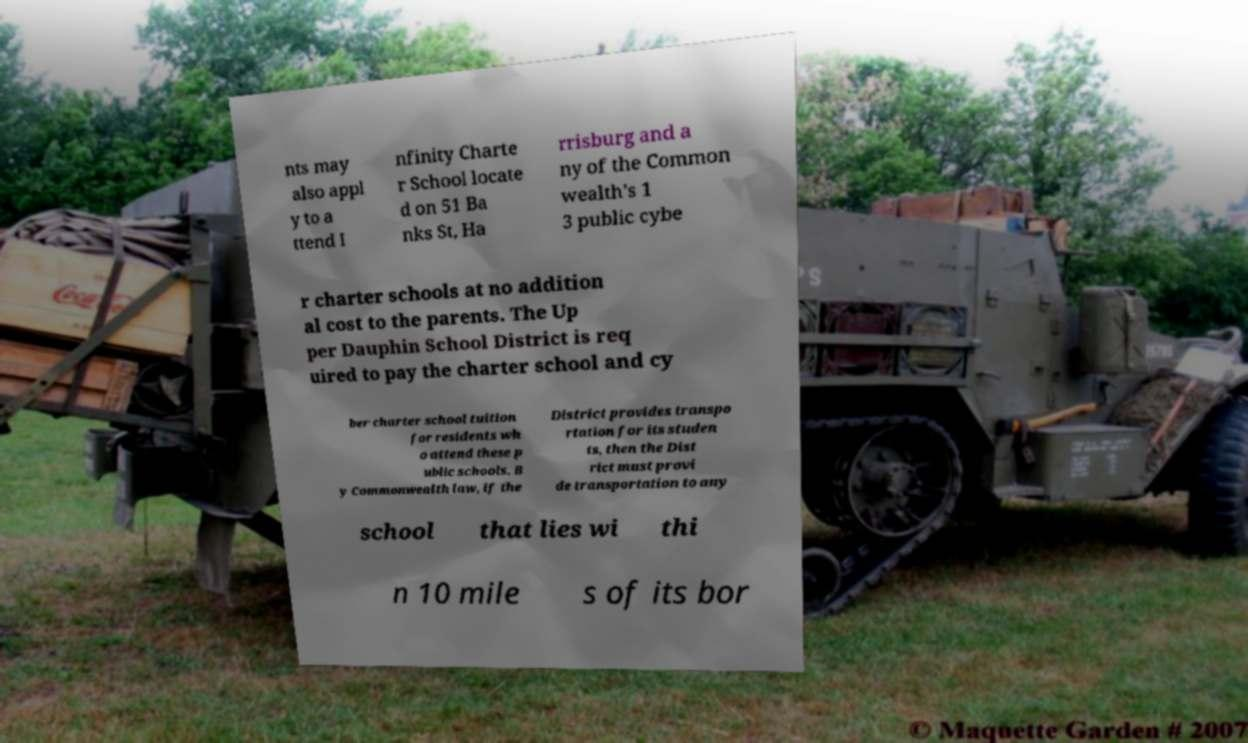I need the written content from this picture converted into text. Can you do that? nts may also appl y to a ttend I nfinity Charte r School locate d on 51 Ba nks St, Ha rrisburg and a ny of the Common wealth's 1 3 public cybe r charter schools at no addition al cost to the parents. The Up per Dauphin School District is req uired to pay the charter school and cy ber charter school tuition for residents wh o attend these p ublic schools. B y Commonwealth law, if the District provides transpo rtation for its studen ts, then the Dist rict must provi de transportation to any school that lies wi thi n 10 mile s of its bor 